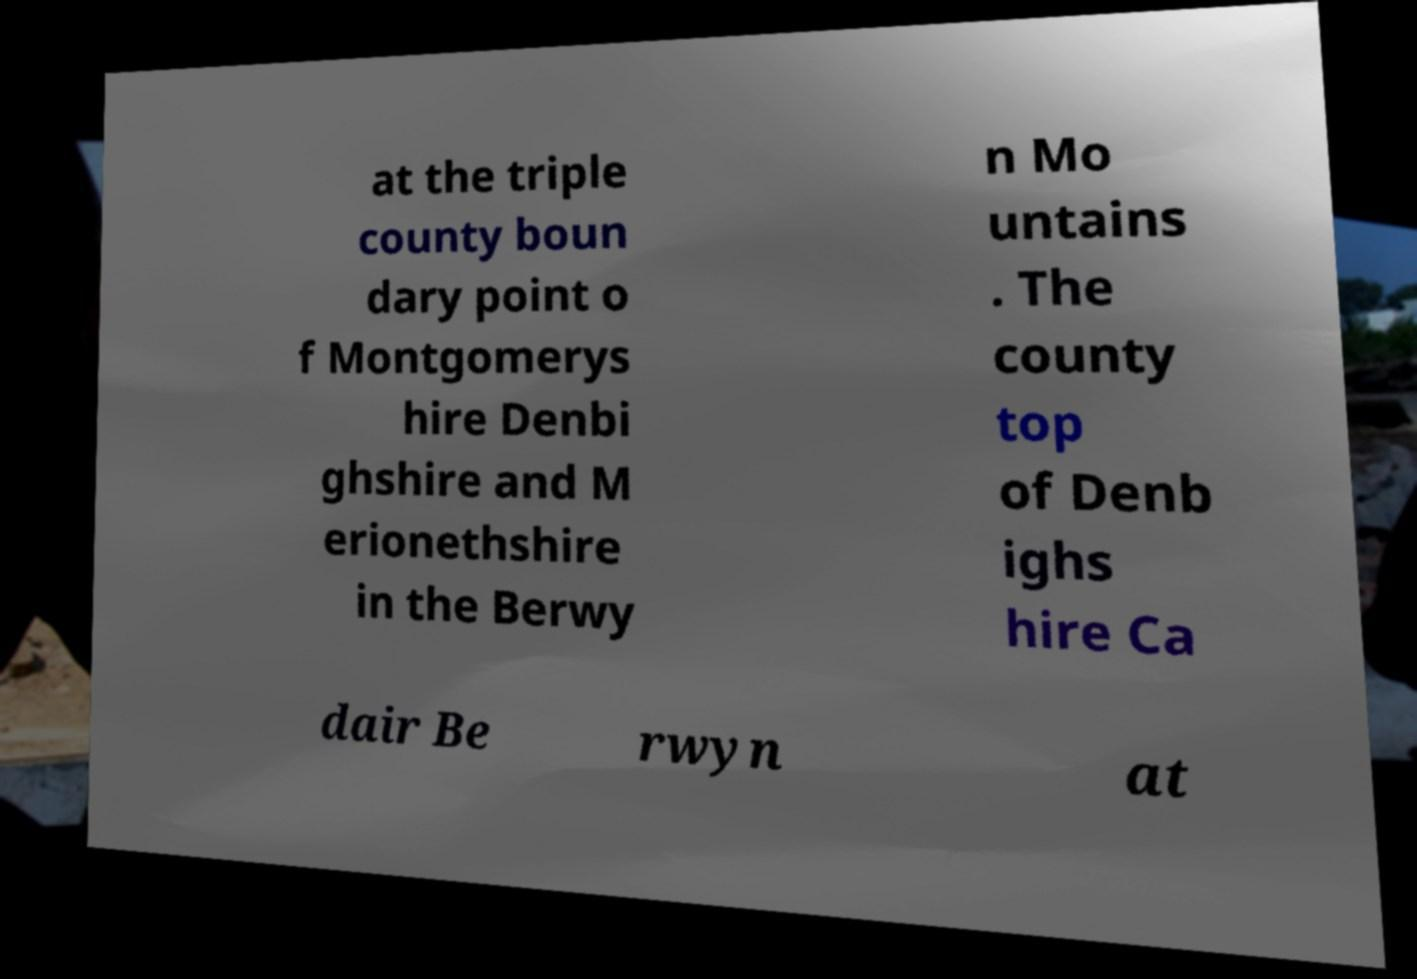There's text embedded in this image that I need extracted. Can you transcribe it verbatim? at the triple county boun dary point o f Montgomerys hire Denbi ghshire and M erionethshire in the Berwy n Mo untains . The county top of Denb ighs hire Ca dair Be rwyn at 